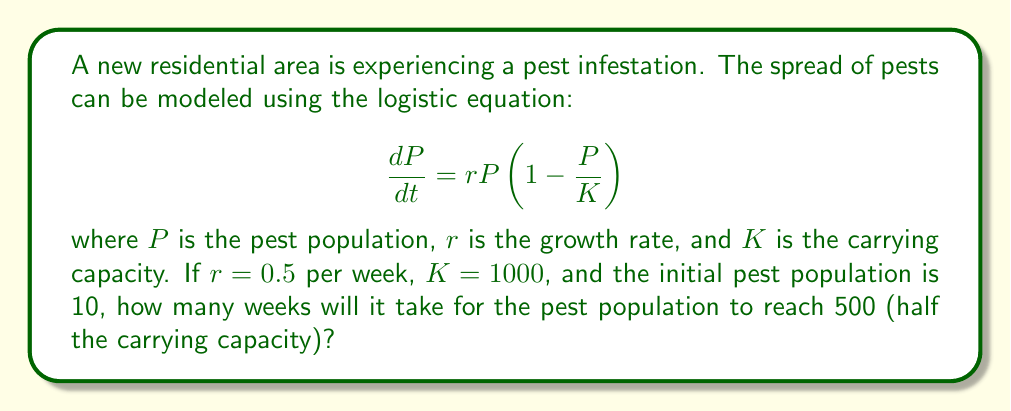Can you solve this math problem? To solve this problem, we need to integrate the logistic equation and solve for time. Let's follow these steps:

1) The solution to the logistic equation is:

   $$P(t) = \frac{K}{1 + (\frac{K}{P_0} - 1)e^{-rt}}$$

   where $P_0$ is the initial population.

2) We're given: $K = 1000$, $r = 0.5$, $P_0 = 10$, and we want to find $t$ when $P(t) = 500$.

3) Substitute these values into the equation:

   $$500 = \frac{1000}{1 + (\frac{1000}{10} - 1)e^{-0.5t}}$$

4) Simplify:
   
   $$500 = \frac{1000}{1 + 99e^{-0.5t}}$$

5) Multiply both sides by $(1 + 99e^{-0.5t})$:

   $$500 + 49500e^{-0.5t} = 1000$$

6) Subtract 500 from both sides:

   $$49500e^{-0.5t} = 500$$

7) Divide both sides by 49500:

   $$e^{-0.5t} = \frac{1}{99}$$

8) Take the natural log of both sides:

   $$-0.5t = \ln(\frac{1}{99}) = -\ln(99)$$

9) Divide both sides by -0.5:

   $$t = \frac{\ln(99)}{0.5} \approx 9.19$$

Therefore, it will take approximately 9.19 weeks for the pest population to reach 500.
Answer: 9.19 weeks 